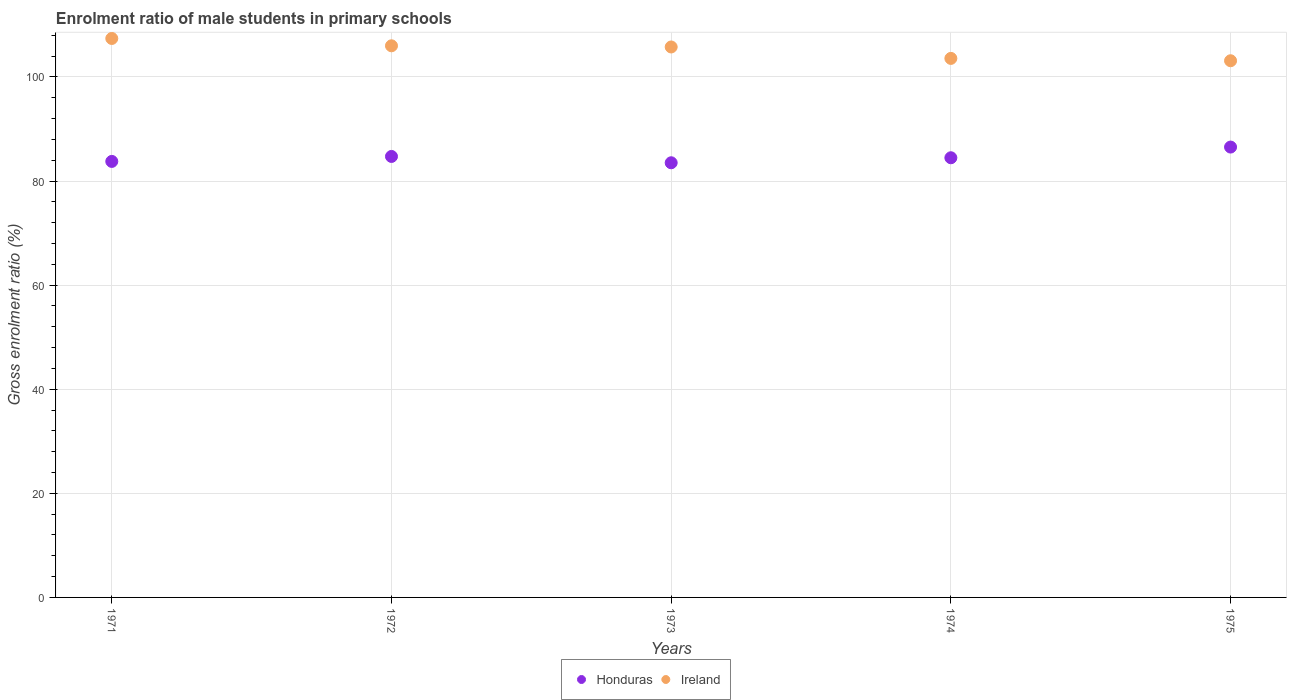How many different coloured dotlines are there?
Offer a terse response. 2. Is the number of dotlines equal to the number of legend labels?
Provide a succinct answer. Yes. What is the enrolment ratio of male students in primary schools in Honduras in 1974?
Your answer should be very brief. 84.47. Across all years, what is the maximum enrolment ratio of male students in primary schools in Ireland?
Offer a terse response. 107.39. Across all years, what is the minimum enrolment ratio of male students in primary schools in Ireland?
Provide a succinct answer. 103.11. In which year was the enrolment ratio of male students in primary schools in Honduras maximum?
Your answer should be compact. 1975. In which year was the enrolment ratio of male students in primary schools in Ireland minimum?
Offer a terse response. 1975. What is the total enrolment ratio of male students in primary schools in Ireland in the graph?
Provide a short and direct response. 525.78. What is the difference between the enrolment ratio of male students in primary schools in Ireland in 1972 and that in 1973?
Provide a short and direct response. 0.23. What is the difference between the enrolment ratio of male students in primary schools in Honduras in 1971 and the enrolment ratio of male students in primary schools in Ireland in 1975?
Your answer should be compact. -19.34. What is the average enrolment ratio of male students in primary schools in Honduras per year?
Your answer should be compact. 84.6. In the year 1975, what is the difference between the enrolment ratio of male students in primary schools in Honduras and enrolment ratio of male students in primary schools in Ireland?
Your answer should be compact. -16.58. What is the ratio of the enrolment ratio of male students in primary schools in Ireland in 1972 to that in 1973?
Offer a very short reply. 1. Is the difference between the enrolment ratio of male students in primary schools in Honduras in 1973 and 1974 greater than the difference between the enrolment ratio of male students in primary schools in Ireland in 1973 and 1974?
Ensure brevity in your answer.  No. What is the difference between the highest and the second highest enrolment ratio of male students in primary schools in Honduras?
Give a very brief answer. 1.8. What is the difference between the highest and the lowest enrolment ratio of male students in primary schools in Ireland?
Make the answer very short. 4.28. Is the enrolment ratio of male students in primary schools in Ireland strictly greater than the enrolment ratio of male students in primary schools in Honduras over the years?
Provide a short and direct response. Yes. Is the enrolment ratio of male students in primary schools in Honduras strictly less than the enrolment ratio of male students in primary schools in Ireland over the years?
Your answer should be very brief. Yes. Where does the legend appear in the graph?
Provide a short and direct response. Bottom center. How many legend labels are there?
Your answer should be very brief. 2. What is the title of the graph?
Ensure brevity in your answer.  Enrolment ratio of male students in primary schools. Does "Pacific island small states" appear as one of the legend labels in the graph?
Give a very brief answer. No. What is the label or title of the X-axis?
Give a very brief answer. Years. What is the label or title of the Y-axis?
Make the answer very short. Gross enrolment ratio (%). What is the Gross enrolment ratio (%) of Honduras in 1971?
Your answer should be very brief. 83.77. What is the Gross enrolment ratio (%) in Ireland in 1971?
Give a very brief answer. 107.39. What is the Gross enrolment ratio (%) in Honduras in 1972?
Your answer should be very brief. 84.72. What is the Gross enrolment ratio (%) in Ireland in 1972?
Provide a short and direct response. 105.98. What is the Gross enrolment ratio (%) in Honduras in 1973?
Give a very brief answer. 83.51. What is the Gross enrolment ratio (%) in Ireland in 1973?
Your answer should be very brief. 105.75. What is the Gross enrolment ratio (%) in Honduras in 1974?
Provide a succinct answer. 84.47. What is the Gross enrolment ratio (%) of Ireland in 1974?
Your response must be concise. 103.56. What is the Gross enrolment ratio (%) in Honduras in 1975?
Make the answer very short. 86.52. What is the Gross enrolment ratio (%) of Ireland in 1975?
Provide a succinct answer. 103.11. Across all years, what is the maximum Gross enrolment ratio (%) in Honduras?
Provide a succinct answer. 86.52. Across all years, what is the maximum Gross enrolment ratio (%) in Ireland?
Provide a short and direct response. 107.39. Across all years, what is the minimum Gross enrolment ratio (%) of Honduras?
Give a very brief answer. 83.51. Across all years, what is the minimum Gross enrolment ratio (%) of Ireland?
Give a very brief answer. 103.11. What is the total Gross enrolment ratio (%) in Honduras in the graph?
Your answer should be very brief. 422.98. What is the total Gross enrolment ratio (%) in Ireland in the graph?
Give a very brief answer. 525.78. What is the difference between the Gross enrolment ratio (%) of Honduras in 1971 and that in 1972?
Make the answer very short. -0.95. What is the difference between the Gross enrolment ratio (%) in Ireland in 1971 and that in 1972?
Your answer should be very brief. 1.41. What is the difference between the Gross enrolment ratio (%) in Honduras in 1971 and that in 1973?
Offer a terse response. 0.26. What is the difference between the Gross enrolment ratio (%) of Ireland in 1971 and that in 1973?
Your answer should be very brief. 1.63. What is the difference between the Gross enrolment ratio (%) of Honduras in 1971 and that in 1974?
Your response must be concise. -0.7. What is the difference between the Gross enrolment ratio (%) in Ireland in 1971 and that in 1974?
Provide a short and direct response. 3.83. What is the difference between the Gross enrolment ratio (%) in Honduras in 1971 and that in 1975?
Provide a succinct answer. -2.76. What is the difference between the Gross enrolment ratio (%) in Ireland in 1971 and that in 1975?
Make the answer very short. 4.28. What is the difference between the Gross enrolment ratio (%) in Honduras in 1972 and that in 1973?
Keep it short and to the point. 1.21. What is the difference between the Gross enrolment ratio (%) of Ireland in 1972 and that in 1973?
Give a very brief answer. 0.23. What is the difference between the Gross enrolment ratio (%) in Honduras in 1972 and that in 1974?
Keep it short and to the point. 0.25. What is the difference between the Gross enrolment ratio (%) in Ireland in 1972 and that in 1974?
Ensure brevity in your answer.  2.42. What is the difference between the Gross enrolment ratio (%) in Honduras in 1972 and that in 1975?
Give a very brief answer. -1.8. What is the difference between the Gross enrolment ratio (%) of Ireland in 1972 and that in 1975?
Your answer should be very brief. 2.87. What is the difference between the Gross enrolment ratio (%) in Honduras in 1973 and that in 1974?
Keep it short and to the point. -0.96. What is the difference between the Gross enrolment ratio (%) in Ireland in 1973 and that in 1974?
Your response must be concise. 2.19. What is the difference between the Gross enrolment ratio (%) in Honduras in 1973 and that in 1975?
Your answer should be very brief. -3.02. What is the difference between the Gross enrolment ratio (%) in Ireland in 1973 and that in 1975?
Your response must be concise. 2.65. What is the difference between the Gross enrolment ratio (%) in Honduras in 1974 and that in 1975?
Make the answer very short. -2.05. What is the difference between the Gross enrolment ratio (%) in Ireland in 1974 and that in 1975?
Your answer should be compact. 0.45. What is the difference between the Gross enrolment ratio (%) of Honduras in 1971 and the Gross enrolment ratio (%) of Ireland in 1972?
Offer a very short reply. -22.21. What is the difference between the Gross enrolment ratio (%) of Honduras in 1971 and the Gross enrolment ratio (%) of Ireland in 1973?
Your answer should be compact. -21.99. What is the difference between the Gross enrolment ratio (%) in Honduras in 1971 and the Gross enrolment ratio (%) in Ireland in 1974?
Provide a short and direct response. -19.79. What is the difference between the Gross enrolment ratio (%) of Honduras in 1971 and the Gross enrolment ratio (%) of Ireland in 1975?
Your answer should be compact. -19.34. What is the difference between the Gross enrolment ratio (%) of Honduras in 1972 and the Gross enrolment ratio (%) of Ireland in 1973?
Offer a terse response. -21.03. What is the difference between the Gross enrolment ratio (%) in Honduras in 1972 and the Gross enrolment ratio (%) in Ireland in 1974?
Make the answer very short. -18.84. What is the difference between the Gross enrolment ratio (%) of Honduras in 1972 and the Gross enrolment ratio (%) of Ireland in 1975?
Provide a succinct answer. -18.39. What is the difference between the Gross enrolment ratio (%) of Honduras in 1973 and the Gross enrolment ratio (%) of Ireland in 1974?
Your answer should be compact. -20.05. What is the difference between the Gross enrolment ratio (%) of Honduras in 1973 and the Gross enrolment ratio (%) of Ireland in 1975?
Ensure brevity in your answer.  -19.6. What is the difference between the Gross enrolment ratio (%) in Honduras in 1974 and the Gross enrolment ratio (%) in Ireland in 1975?
Give a very brief answer. -18.64. What is the average Gross enrolment ratio (%) in Honduras per year?
Give a very brief answer. 84.6. What is the average Gross enrolment ratio (%) in Ireland per year?
Your response must be concise. 105.16. In the year 1971, what is the difference between the Gross enrolment ratio (%) in Honduras and Gross enrolment ratio (%) in Ireland?
Your answer should be compact. -23.62. In the year 1972, what is the difference between the Gross enrolment ratio (%) of Honduras and Gross enrolment ratio (%) of Ireland?
Your answer should be very brief. -21.26. In the year 1973, what is the difference between the Gross enrolment ratio (%) of Honduras and Gross enrolment ratio (%) of Ireland?
Your answer should be compact. -22.25. In the year 1974, what is the difference between the Gross enrolment ratio (%) in Honduras and Gross enrolment ratio (%) in Ireland?
Offer a very short reply. -19.09. In the year 1975, what is the difference between the Gross enrolment ratio (%) in Honduras and Gross enrolment ratio (%) in Ireland?
Provide a succinct answer. -16.58. What is the ratio of the Gross enrolment ratio (%) of Honduras in 1971 to that in 1972?
Make the answer very short. 0.99. What is the ratio of the Gross enrolment ratio (%) of Ireland in 1971 to that in 1972?
Give a very brief answer. 1.01. What is the ratio of the Gross enrolment ratio (%) in Ireland in 1971 to that in 1973?
Make the answer very short. 1.02. What is the ratio of the Gross enrolment ratio (%) in Honduras in 1971 to that in 1974?
Your answer should be compact. 0.99. What is the ratio of the Gross enrolment ratio (%) in Honduras in 1971 to that in 1975?
Your response must be concise. 0.97. What is the ratio of the Gross enrolment ratio (%) in Ireland in 1971 to that in 1975?
Provide a short and direct response. 1.04. What is the ratio of the Gross enrolment ratio (%) in Honduras in 1972 to that in 1973?
Your answer should be very brief. 1.01. What is the ratio of the Gross enrolment ratio (%) of Ireland in 1972 to that in 1973?
Offer a very short reply. 1. What is the ratio of the Gross enrolment ratio (%) of Ireland in 1972 to that in 1974?
Provide a short and direct response. 1.02. What is the ratio of the Gross enrolment ratio (%) of Honduras in 1972 to that in 1975?
Provide a short and direct response. 0.98. What is the ratio of the Gross enrolment ratio (%) of Ireland in 1972 to that in 1975?
Your answer should be compact. 1.03. What is the ratio of the Gross enrolment ratio (%) of Ireland in 1973 to that in 1974?
Provide a succinct answer. 1.02. What is the ratio of the Gross enrolment ratio (%) of Honduras in 1973 to that in 1975?
Ensure brevity in your answer.  0.97. What is the ratio of the Gross enrolment ratio (%) of Ireland in 1973 to that in 1975?
Provide a short and direct response. 1.03. What is the ratio of the Gross enrolment ratio (%) of Honduras in 1974 to that in 1975?
Keep it short and to the point. 0.98. What is the ratio of the Gross enrolment ratio (%) in Ireland in 1974 to that in 1975?
Offer a very short reply. 1. What is the difference between the highest and the second highest Gross enrolment ratio (%) in Honduras?
Make the answer very short. 1.8. What is the difference between the highest and the second highest Gross enrolment ratio (%) in Ireland?
Your answer should be compact. 1.41. What is the difference between the highest and the lowest Gross enrolment ratio (%) in Honduras?
Your response must be concise. 3.02. What is the difference between the highest and the lowest Gross enrolment ratio (%) of Ireland?
Give a very brief answer. 4.28. 